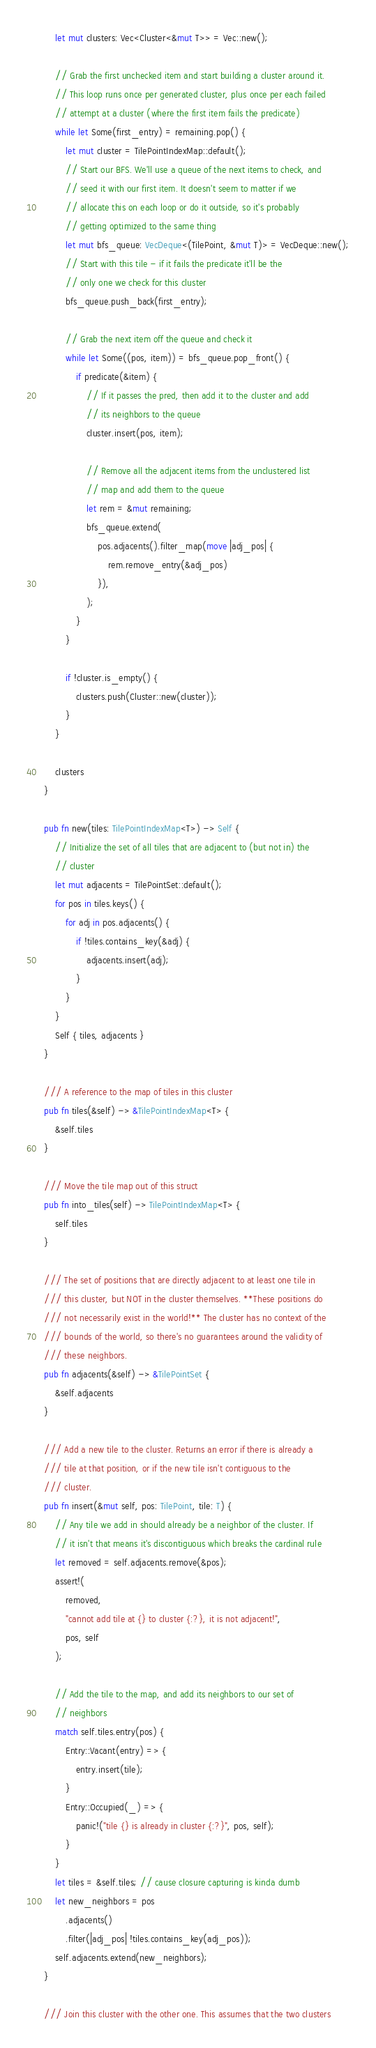Convert code to text. <code><loc_0><loc_0><loc_500><loc_500><_Rust_>        let mut clusters: Vec<Cluster<&mut T>> = Vec::new();

        // Grab the first unchecked item and start building a cluster around it.
        // This loop runs once per generated cluster, plus once per each failed
        // attempt at a cluster (where the first item fails the predicate)
        while let Some(first_entry) = remaining.pop() {
            let mut cluster = TilePointIndexMap::default();
            // Start our BFS. We'll use a queue of the next items to check, and
            // seed it with our first item. It doesn't seem to matter if we
            // allocate this on each loop or do it outside, so it's probably
            // getting optimized to the same thing
            let mut bfs_queue: VecDeque<(TilePoint, &mut T)> = VecDeque::new();
            // Start with this tile - if it fails the predicate it'll be the
            // only one we check for this cluster
            bfs_queue.push_back(first_entry);

            // Grab the next item off the queue and check it
            while let Some((pos, item)) = bfs_queue.pop_front() {
                if predicate(&item) {
                    // If it passes the pred, then add it to the cluster and add
                    // its neighbors to the queue
                    cluster.insert(pos, item);

                    // Remove all the adjacent items from the unclustered list
                    // map and add them to the queue
                    let rem = &mut remaining;
                    bfs_queue.extend(
                        pos.adjacents().filter_map(move |adj_pos| {
                            rem.remove_entry(&adj_pos)
                        }),
                    );
                }
            }

            if !cluster.is_empty() {
                clusters.push(Cluster::new(cluster));
            }
        }

        clusters
    }

    pub fn new(tiles: TilePointIndexMap<T>) -> Self {
        // Initialize the set of all tiles that are adjacent to (but not in) the
        // cluster
        let mut adjacents = TilePointSet::default();
        for pos in tiles.keys() {
            for adj in pos.adjacents() {
                if !tiles.contains_key(&adj) {
                    adjacents.insert(adj);
                }
            }
        }
        Self { tiles, adjacents }
    }

    /// A reference to the map of tiles in this cluster
    pub fn tiles(&self) -> &TilePointIndexMap<T> {
        &self.tiles
    }

    /// Move the tile map out of this struct
    pub fn into_tiles(self) -> TilePointIndexMap<T> {
        self.tiles
    }

    /// The set of positions that are directly adjacent to at least one tile in
    /// this cluster, but NOT in the cluster themselves. **These positions do
    /// not necessarily exist in the world!** The cluster has no context of the
    /// bounds of the world, so there's no guarantees around the validity of
    /// these neighbors.
    pub fn adjacents(&self) -> &TilePointSet {
        &self.adjacents
    }

    /// Add a new tile to the cluster. Returns an error if there is already a
    /// tile at that position, or if the new tile isn't contiguous to the
    /// cluster.
    pub fn insert(&mut self, pos: TilePoint, tile: T) {
        // Any tile we add in should already be a neighbor of the cluster. If
        // it isn't that means it's discontiguous which breaks the cardinal rule
        let removed = self.adjacents.remove(&pos);
        assert!(
            removed,
            "cannot add tile at {} to cluster {:?}, it is not adjacent!",
            pos, self
        );

        // Add the tile to the map, and add its neighbors to our set of
        // neighbors
        match self.tiles.entry(pos) {
            Entry::Vacant(entry) => {
                entry.insert(tile);
            }
            Entry::Occupied(_) => {
                panic!("tile {} is already in cluster {:?}", pos, self);
            }
        }
        let tiles = &self.tiles; // cause closure capturing is kinda dumb
        let new_neighbors = pos
            .adjacents()
            .filter(|adj_pos| !tiles.contains_key(adj_pos));
        self.adjacents.extend(new_neighbors);
    }

    /// Join this cluster with the other one. This assumes that the two clusters</code> 